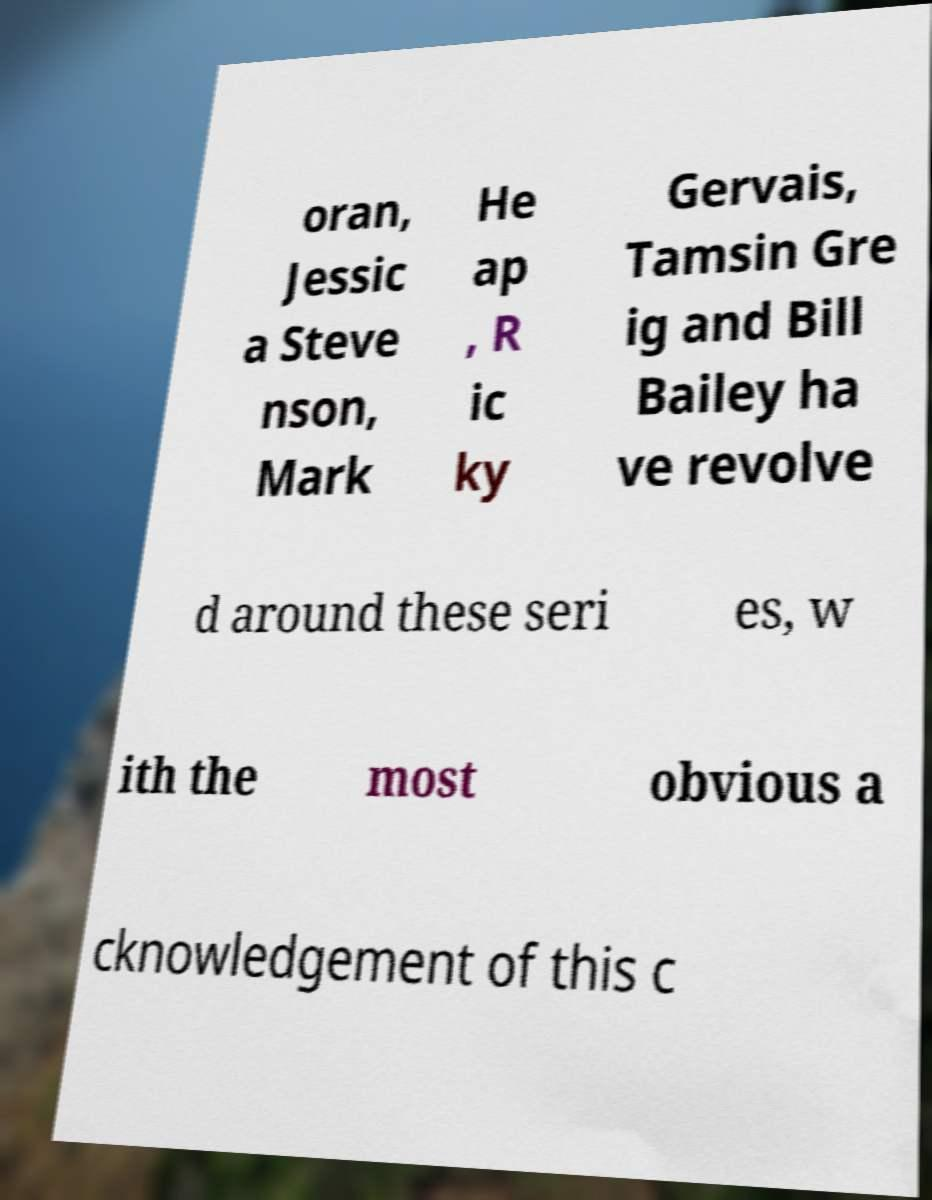There's text embedded in this image that I need extracted. Can you transcribe it verbatim? oran, Jessic a Steve nson, Mark He ap , R ic ky Gervais, Tamsin Gre ig and Bill Bailey ha ve revolve d around these seri es, w ith the most obvious a cknowledgement of this c 